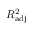Convert formula to latex. <formula><loc_0><loc_0><loc_500><loc_500>R _ { a d j } ^ { 2 }</formula> 